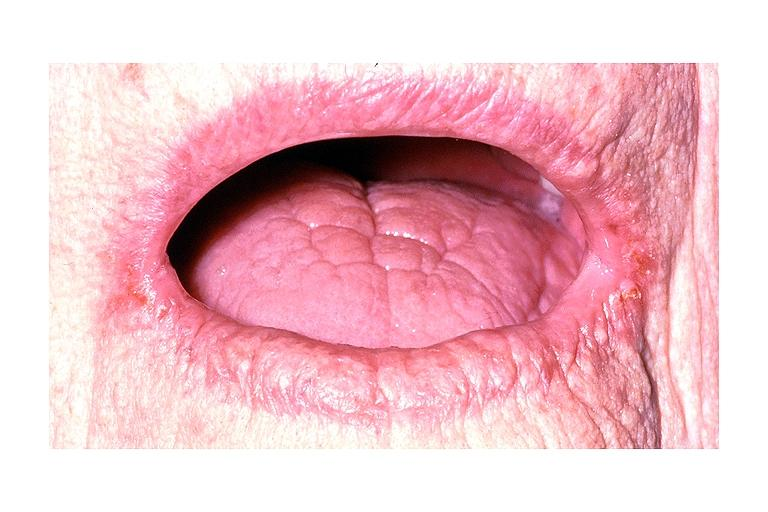where is this?
Answer the question using a single word or phrase. Oral 